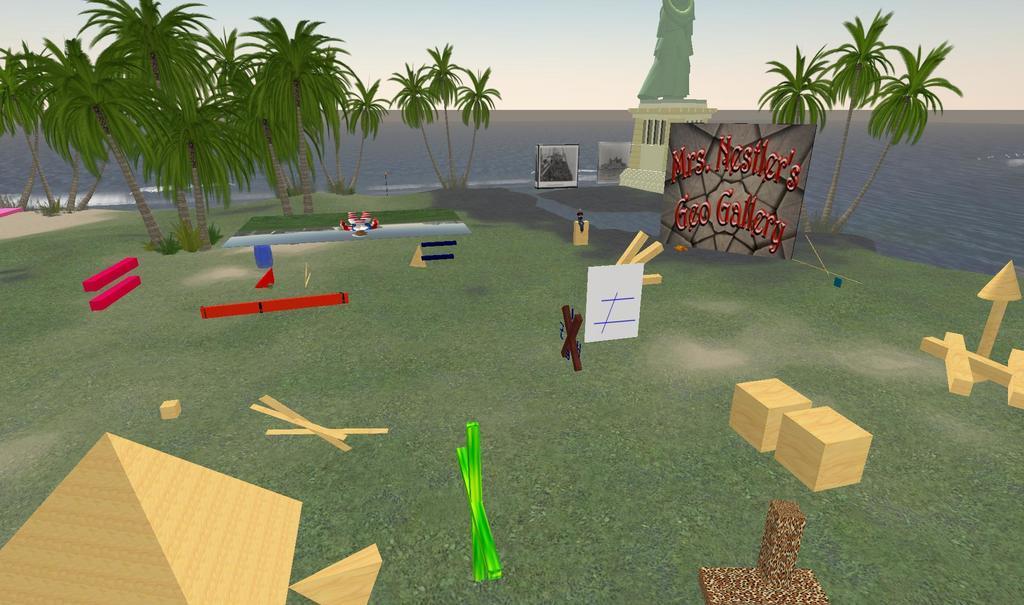Please provide a concise description of this image. In this image I can see the digital art. I can see few trees, few shapes which are brown in color and few objects which are red, black, green and blue in color and in the background I can see a statue, a board, few trees and the water. 